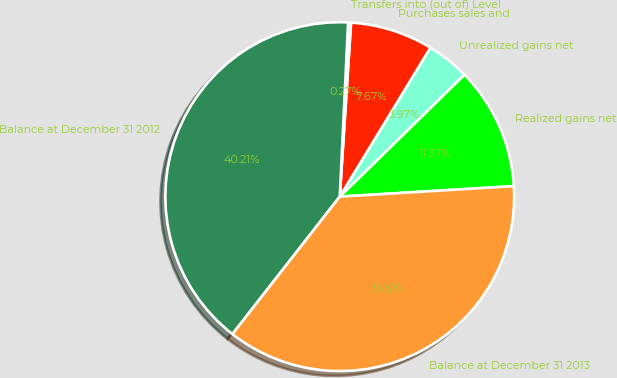Convert chart to OTSL. <chart><loc_0><loc_0><loc_500><loc_500><pie_chart><fcel>Realized gains net<fcel>Unrealized gains net<fcel>Purchases sales and<fcel>Transfers into (out of) Level<fcel>Balance at December 31 2012<fcel>Balance at December 31 2013<nl><fcel>11.37%<fcel>3.97%<fcel>7.67%<fcel>0.27%<fcel>40.21%<fcel>36.51%<nl></chart> 